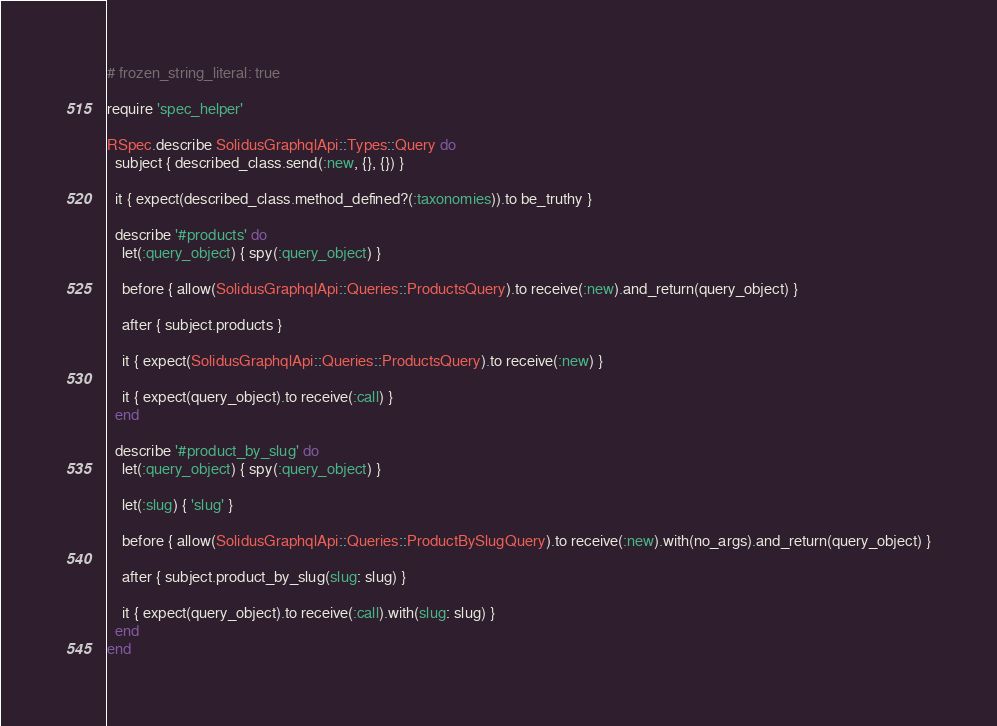Convert code to text. <code><loc_0><loc_0><loc_500><loc_500><_Ruby_># frozen_string_literal: true

require 'spec_helper'

RSpec.describe SolidusGraphqlApi::Types::Query do
  subject { described_class.send(:new, {}, {}) }

  it { expect(described_class.method_defined?(:taxonomies)).to be_truthy }

  describe '#products' do
    let(:query_object) { spy(:query_object) }

    before { allow(SolidusGraphqlApi::Queries::ProductsQuery).to receive(:new).and_return(query_object) }

    after { subject.products }

    it { expect(SolidusGraphqlApi::Queries::ProductsQuery).to receive(:new) }

    it { expect(query_object).to receive(:call) }
  end

  describe '#product_by_slug' do
    let(:query_object) { spy(:query_object) }

    let(:slug) { 'slug' }

    before { allow(SolidusGraphqlApi::Queries::ProductBySlugQuery).to receive(:new).with(no_args).and_return(query_object) }

    after { subject.product_by_slug(slug: slug) }

    it { expect(query_object).to receive(:call).with(slug: slug) }
  end
end
</code> 